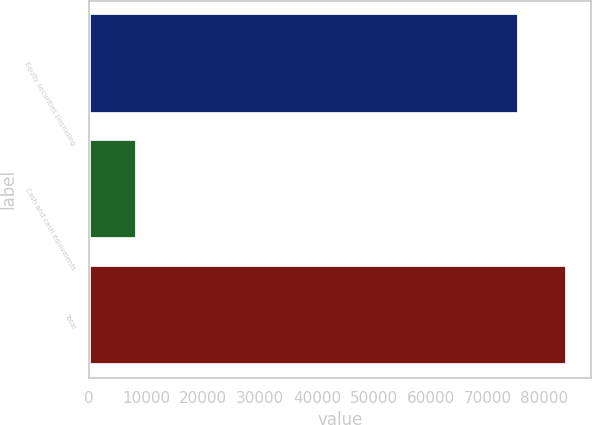Convert chart. <chart><loc_0><loc_0><loc_500><loc_500><bar_chart><fcel>Equity securities (including<fcel>Cash and cash equivalents<fcel>Total<nl><fcel>75601<fcel>8365<fcel>83966<nl></chart> 